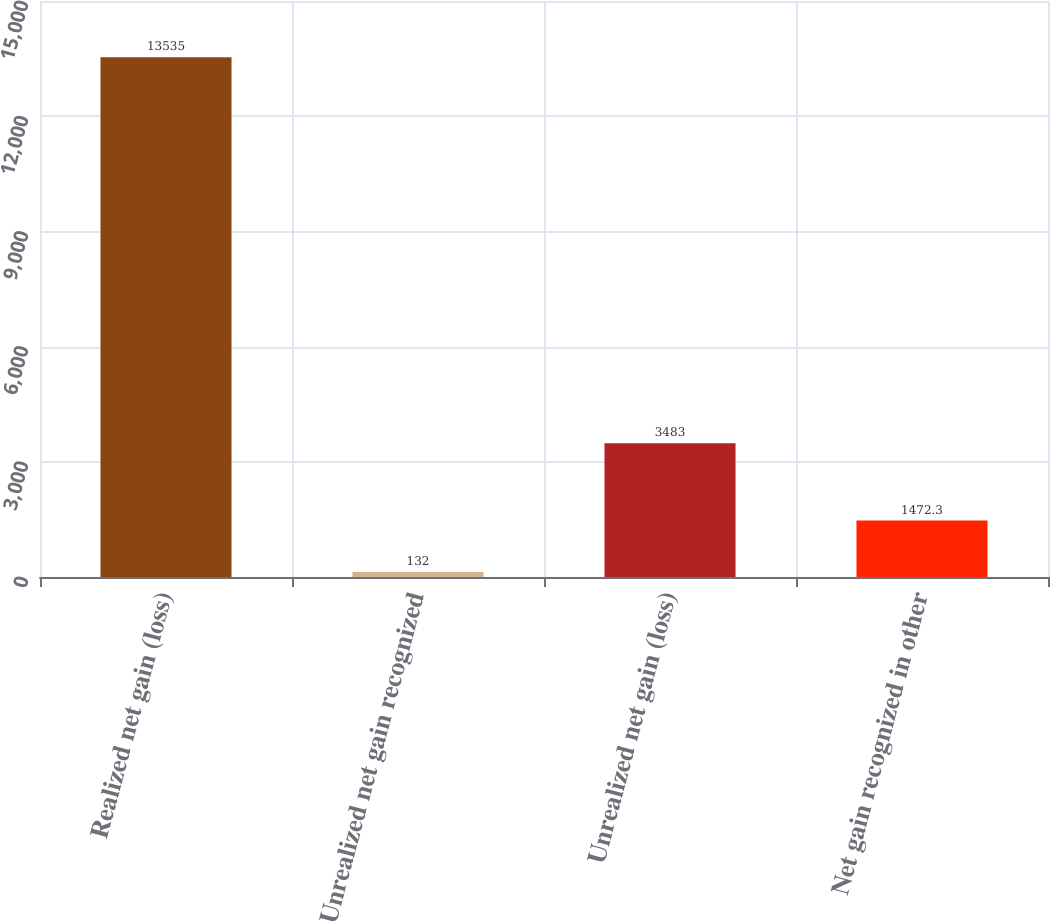<chart> <loc_0><loc_0><loc_500><loc_500><bar_chart><fcel>Realized net gain (loss)<fcel>Unrealized net gain recognized<fcel>Unrealized net gain (loss)<fcel>Net gain recognized in other<nl><fcel>13535<fcel>132<fcel>3483<fcel>1472.3<nl></chart> 